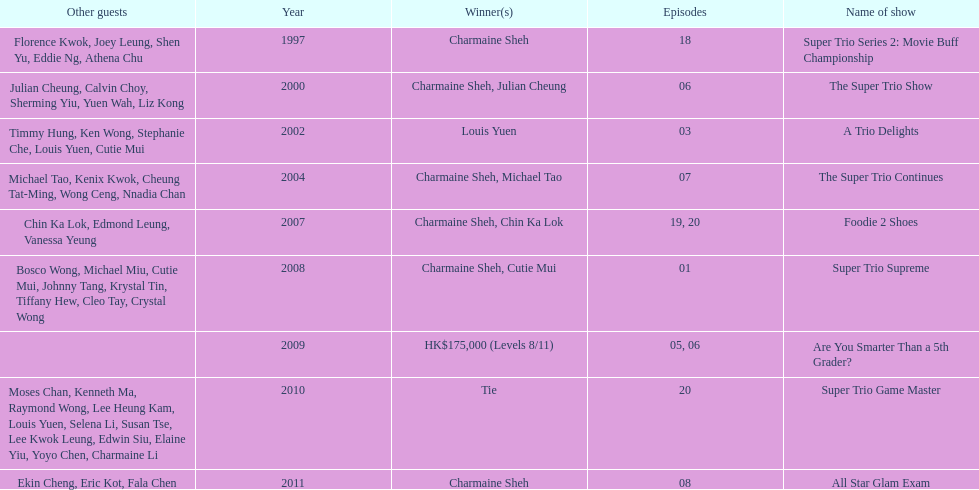How long has it been since chermaine sheh first appeared on a variety show? 17 years. 